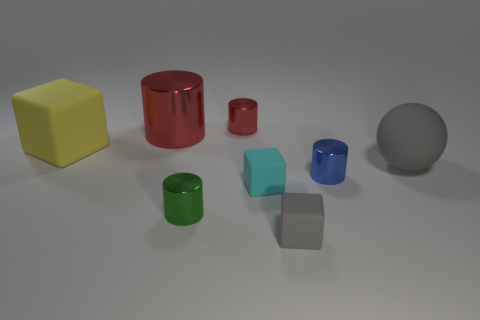Is there anything else that is the same shape as the big gray matte thing?
Provide a succinct answer. No. There is a tiny gray rubber object; is its shape the same as the gray object behind the green shiny cylinder?
Ensure brevity in your answer.  No. What is the shape of the large matte object that is left of the gray sphere?
Make the answer very short. Cube. Do the cyan rubber object and the big red metal object have the same shape?
Ensure brevity in your answer.  No. There is a green metal object that is the same shape as the tiny red thing; what size is it?
Provide a succinct answer. Small. Does the gray thing on the left side of the blue thing have the same size as the small green cylinder?
Offer a terse response. Yes. What is the size of the rubber object that is in front of the tiny blue shiny cylinder and on the left side of the tiny gray block?
Your answer should be compact. Small. There is a small cylinder that is the same color as the big shiny thing; what is it made of?
Offer a very short reply. Metal. What number of shiny objects have the same color as the large cylinder?
Your answer should be very brief. 1. Is the number of yellow objects right of the large metal cylinder the same as the number of gray rubber cylinders?
Your answer should be very brief. Yes. 